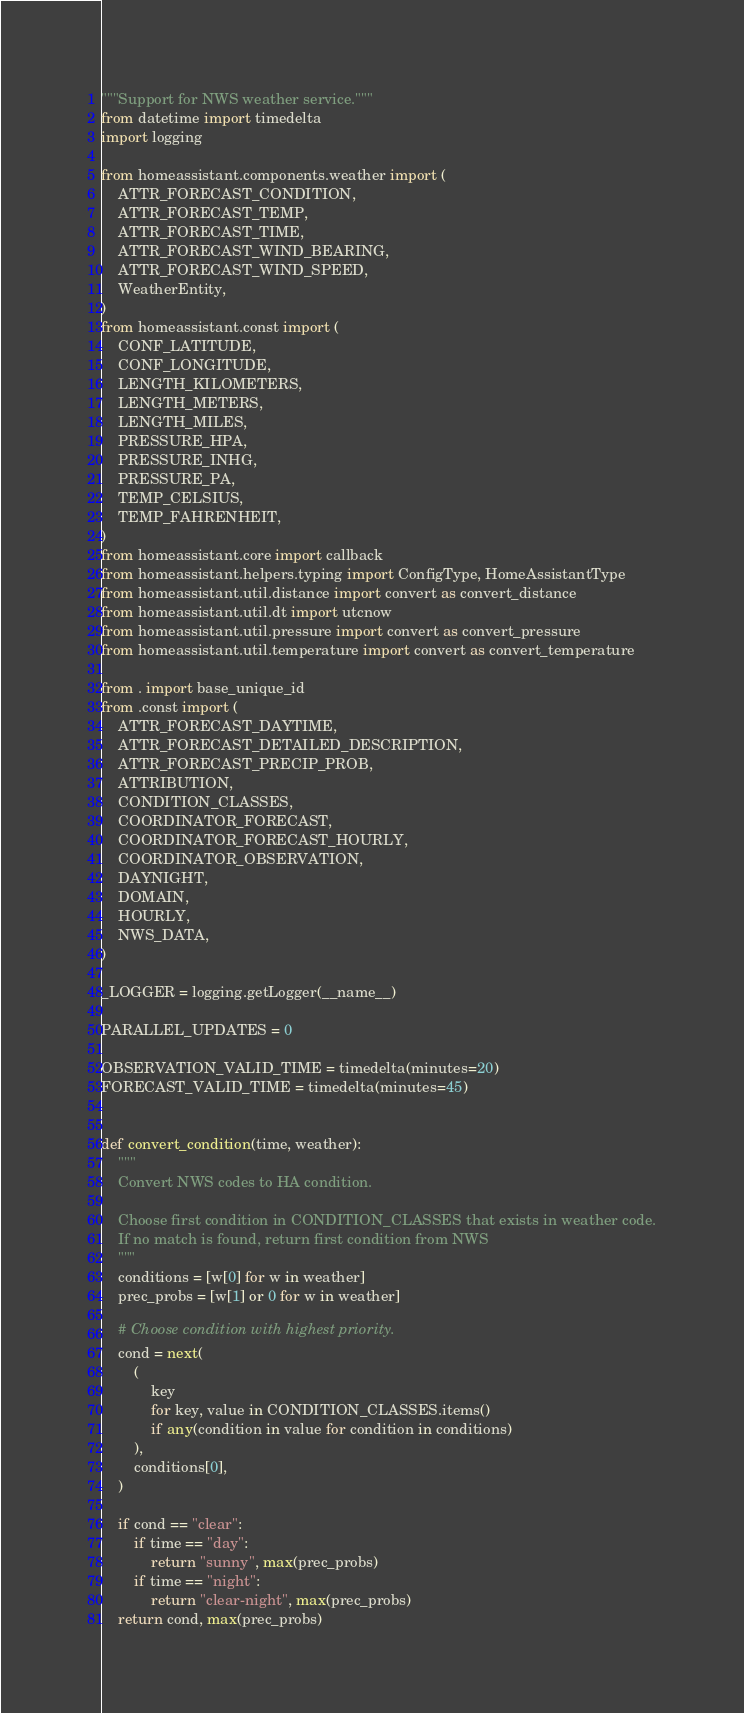Convert code to text. <code><loc_0><loc_0><loc_500><loc_500><_Python_>"""Support for NWS weather service."""
from datetime import timedelta
import logging

from homeassistant.components.weather import (
    ATTR_FORECAST_CONDITION,
    ATTR_FORECAST_TEMP,
    ATTR_FORECAST_TIME,
    ATTR_FORECAST_WIND_BEARING,
    ATTR_FORECAST_WIND_SPEED,
    WeatherEntity,
)
from homeassistant.const import (
    CONF_LATITUDE,
    CONF_LONGITUDE,
    LENGTH_KILOMETERS,
    LENGTH_METERS,
    LENGTH_MILES,
    PRESSURE_HPA,
    PRESSURE_INHG,
    PRESSURE_PA,
    TEMP_CELSIUS,
    TEMP_FAHRENHEIT,
)
from homeassistant.core import callback
from homeassistant.helpers.typing import ConfigType, HomeAssistantType
from homeassistant.util.distance import convert as convert_distance
from homeassistant.util.dt import utcnow
from homeassistant.util.pressure import convert as convert_pressure
from homeassistant.util.temperature import convert as convert_temperature

from . import base_unique_id
from .const import (
    ATTR_FORECAST_DAYTIME,
    ATTR_FORECAST_DETAILED_DESCRIPTION,
    ATTR_FORECAST_PRECIP_PROB,
    ATTRIBUTION,
    CONDITION_CLASSES,
    COORDINATOR_FORECAST,
    COORDINATOR_FORECAST_HOURLY,
    COORDINATOR_OBSERVATION,
    DAYNIGHT,
    DOMAIN,
    HOURLY,
    NWS_DATA,
)

_LOGGER = logging.getLogger(__name__)

PARALLEL_UPDATES = 0

OBSERVATION_VALID_TIME = timedelta(minutes=20)
FORECAST_VALID_TIME = timedelta(minutes=45)


def convert_condition(time, weather):
    """
    Convert NWS codes to HA condition.

    Choose first condition in CONDITION_CLASSES that exists in weather code.
    If no match is found, return first condition from NWS
    """
    conditions = [w[0] for w in weather]
    prec_probs = [w[1] or 0 for w in weather]

    # Choose condition with highest priority.
    cond = next(
        (
            key
            for key, value in CONDITION_CLASSES.items()
            if any(condition in value for condition in conditions)
        ),
        conditions[0],
    )

    if cond == "clear":
        if time == "day":
            return "sunny", max(prec_probs)
        if time == "night":
            return "clear-night", max(prec_probs)
    return cond, max(prec_probs)

</code> 